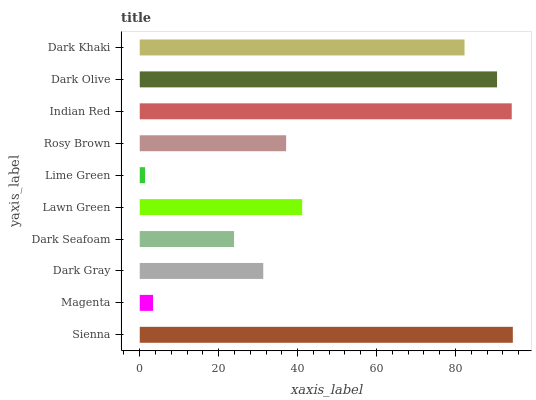Is Lime Green the minimum?
Answer yes or no. Yes. Is Sienna the maximum?
Answer yes or no. Yes. Is Magenta the minimum?
Answer yes or no. No. Is Magenta the maximum?
Answer yes or no. No. Is Sienna greater than Magenta?
Answer yes or no. Yes. Is Magenta less than Sienna?
Answer yes or no. Yes. Is Magenta greater than Sienna?
Answer yes or no. No. Is Sienna less than Magenta?
Answer yes or no. No. Is Lawn Green the high median?
Answer yes or no. Yes. Is Rosy Brown the low median?
Answer yes or no. Yes. Is Dark Gray the high median?
Answer yes or no. No. Is Sienna the low median?
Answer yes or no. No. 